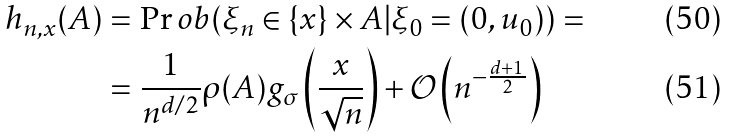Convert formula to latex. <formula><loc_0><loc_0><loc_500><loc_500>h _ { n , x } ( A ) & = \Pr o b ( \xi _ { n } \in \{ x \} \times A | \xi _ { 0 } = ( 0 , u _ { 0 } ) ) = \\ & = \frac { 1 } { n ^ { d / 2 } } \rho ( A ) g _ { \sigma } \left ( \frac { x } { \sqrt { n } } \right ) + \mathcal { O } \left ( n ^ { - \frac { d + 1 } { 2 } } \right )</formula> 